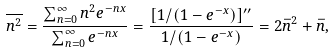Convert formula to latex. <formula><loc_0><loc_0><loc_500><loc_500>\overline { n ^ { 2 } } = \frac { \sum _ { n = 0 } ^ { \infty } n ^ { 2 } e ^ { - n x } } { \sum _ { n = 0 } ^ { \infty } e ^ { - n x } } = \frac { [ 1 / ( 1 - e ^ { - x } ) ] ^ { \prime \prime } } { 1 / ( 1 - e ^ { - x } ) } = 2 \bar { n } ^ { 2 } + \bar { n } ,</formula> 